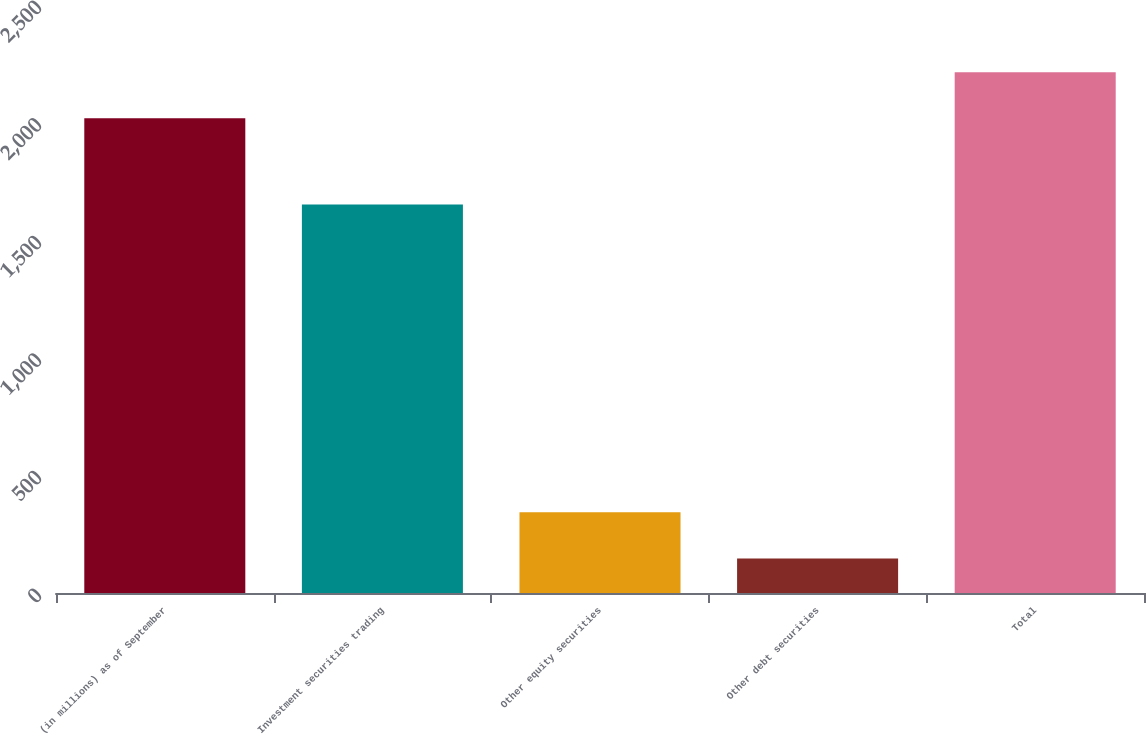<chart> <loc_0><loc_0><loc_500><loc_500><bar_chart><fcel>(in millions) as of September<fcel>Investment securities trading<fcel>Other equity securities<fcel>Other debt securities<fcel>Total<nl><fcel>2018<fcel>1651.8<fcel>342.88<fcel>146.6<fcel>2214.28<nl></chart> 